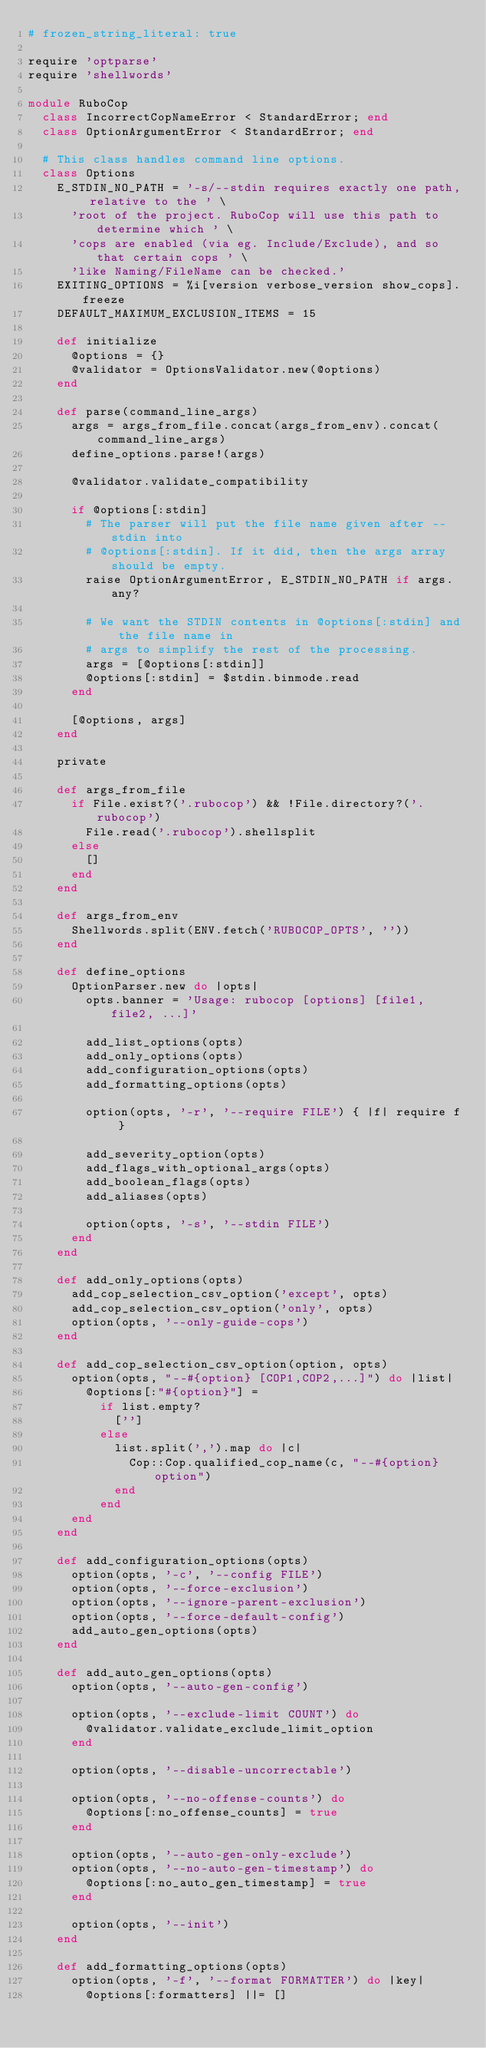Convert code to text. <code><loc_0><loc_0><loc_500><loc_500><_Ruby_># frozen_string_literal: true

require 'optparse'
require 'shellwords'

module RuboCop
  class IncorrectCopNameError < StandardError; end
  class OptionArgumentError < StandardError; end

  # This class handles command line options.
  class Options
    E_STDIN_NO_PATH = '-s/--stdin requires exactly one path, relative to the ' \
      'root of the project. RuboCop will use this path to determine which ' \
      'cops are enabled (via eg. Include/Exclude), and so that certain cops ' \
      'like Naming/FileName can be checked.'
    EXITING_OPTIONS = %i[version verbose_version show_cops].freeze
    DEFAULT_MAXIMUM_EXCLUSION_ITEMS = 15

    def initialize
      @options = {}
      @validator = OptionsValidator.new(@options)
    end

    def parse(command_line_args)
      args = args_from_file.concat(args_from_env).concat(command_line_args)
      define_options.parse!(args)

      @validator.validate_compatibility

      if @options[:stdin]
        # The parser will put the file name given after --stdin into
        # @options[:stdin]. If it did, then the args array should be empty.
        raise OptionArgumentError, E_STDIN_NO_PATH if args.any?

        # We want the STDIN contents in @options[:stdin] and the file name in
        # args to simplify the rest of the processing.
        args = [@options[:stdin]]
        @options[:stdin] = $stdin.binmode.read
      end

      [@options, args]
    end

    private

    def args_from_file
      if File.exist?('.rubocop') && !File.directory?('.rubocop')
        File.read('.rubocop').shellsplit
      else
        []
      end
    end

    def args_from_env
      Shellwords.split(ENV.fetch('RUBOCOP_OPTS', ''))
    end

    def define_options
      OptionParser.new do |opts|
        opts.banner = 'Usage: rubocop [options] [file1, file2, ...]'

        add_list_options(opts)
        add_only_options(opts)
        add_configuration_options(opts)
        add_formatting_options(opts)

        option(opts, '-r', '--require FILE') { |f| require f }

        add_severity_option(opts)
        add_flags_with_optional_args(opts)
        add_boolean_flags(opts)
        add_aliases(opts)

        option(opts, '-s', '--stdin FILE')
      end
    end

    def add_only_options(opts)
      add_cop_selection_csv_option('except', opts)
      add_cop_selection_csv_option('only', opts)
      option(opts, '--only-guide-cops')
    end

    def add_cop_selection_csv_option(option, opts)
      option(opts, "--#{option} [COP1,COP2,...]") do |list|
        @options[:"#{option}"] =
          if list.empty?
            ['']
          else
            list.split(',').map do |c|
              Cop::Cop.qualified_cop_name(c, "--#{option} option")
            end
          end
      end
    end

    def add_configuration_options(opts)
      option(opts, '-c', '--config FILE')
      option(opts, '--force-exclusion')
      option(opts, '--ignore-parent-exclusion')
      option(opts, '--force-default-config')
      add_auto_gen_options(opts)
    end

    def add_auto_gen_options(opts)
      option(opts, '--auto-gen-config')

      option(opts, '--exclude-limit COUNT') do
        @validator.validate_exclude_limit_option
      end

      option(opts, '--disable-uncorrectable')

      option(opts, '--no-offense-counts') do
        @options[:no_offense_counts] = true
      end

      option(opts, '--auto-gen-only-exclude')
      option(opts, '--no-auto-gen-timestamp') do
        @options[:no_auto_gen_timestamp] = true
      end

      option(opts, '--init')
    end

    def add_formatting_options(opts)
      option(opts, '-f', '--format FORMATTER') do |key|
        @options[:formatters] ||= []</code> 